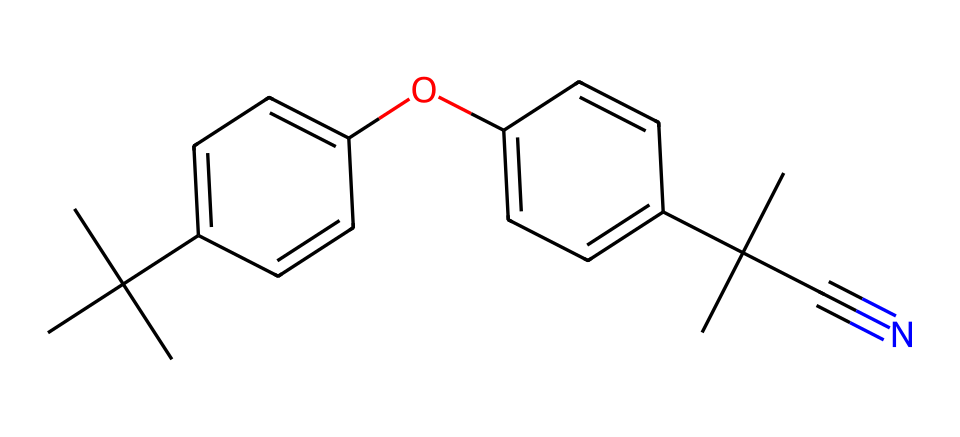What is the total number of carbon atoms in the compound? Analyzing the SMILES representation, we count each 'C' in the structure, which depicts carbon atoms. The given structure contains 22 carbon atoms.
Answer: 22 How many hydroxyl (OH) groups are present in the chemical structure? The presence of the 'O' in the structure linked to a carbon and the surrounding hydrogen indicates a hydroxyl group. There is one such 'O' linked to a carbon in this SMILES, showing one OH group.
Answer: 1 What type of aromatic system does this compound contain? The presence of the 'c' in the SMILES representation signifies that the chemical contains aromatic carbon atoms, specifically a biphenyl structure due to two aromatic rings connected through a linkage.
Answer: biphenyl Is there a nitrile group in this structure? The presence of the '#N' in the SMILES indicates a triple bond between a carbon and a nitrogen atom, confirming the existence of a nitrile group in the compound.
Answer: yes What is the molecular formula of the compound? By counting carbon, hydrogen, oxygen, and nitrogen from the SMILES, we can formulate the molecular formula. In this case, it's C22H30N1O1.
Answer: C22H30N1O1 How many double bonds are present in this aromatic compound? Counting all the implied double bonds associated with the aromatic carbon atoms (as indicated by their connections), there are five double bonds present in this structure.
Answer: 5 